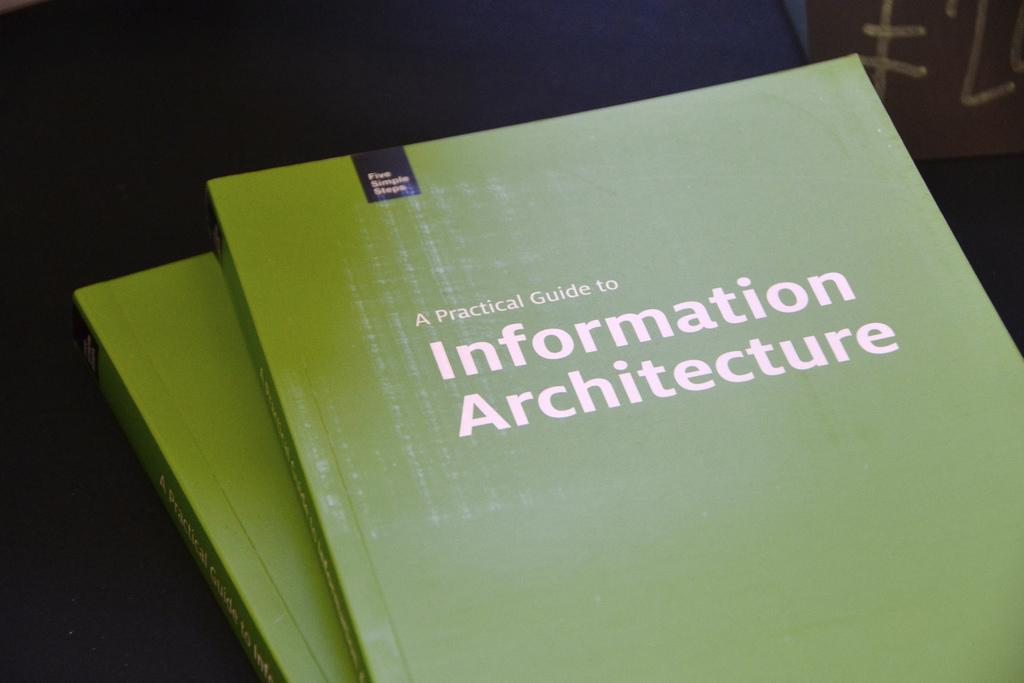<image>
Offer a succinct explanation of the picture presented. two green Information Architecture pamphlets on a table 